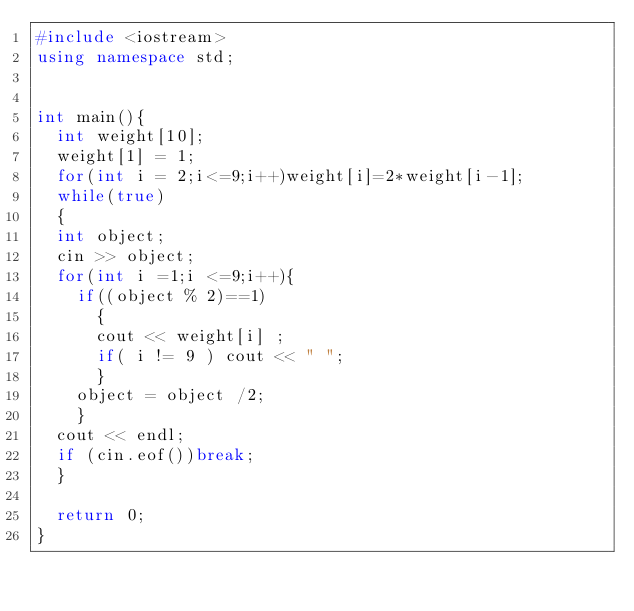Convert code to text. <code><loc_0><loc_0><loc_500><loc_500><_C++_>#include <iostream>
using namespace std;


int main(){
	int weight[10];
	weight[1] = 1;
	for(int i = 2;i<=9;i++)weight[i]=2*weight[i-1];
	while(true)
	{
	int object;
	cin >> object;
	for(int i =1;i <=9;i++){
		if((object % 2)==1)
			{
			cout << weight[i] ;
			if( i != 9 ) cout << " ";
			}
		object = object /2;
		}
	cout << endl;
	if (cin.eof())break;
	}
	
	return 0;
}</code> 